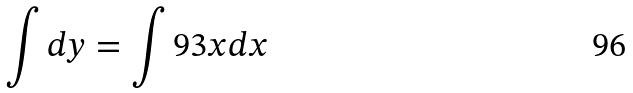Convert formula to latex. <formula><loc_0><loc_0><loc_500><loc_500>\int d y = \int 9 3 x d x</formula> 